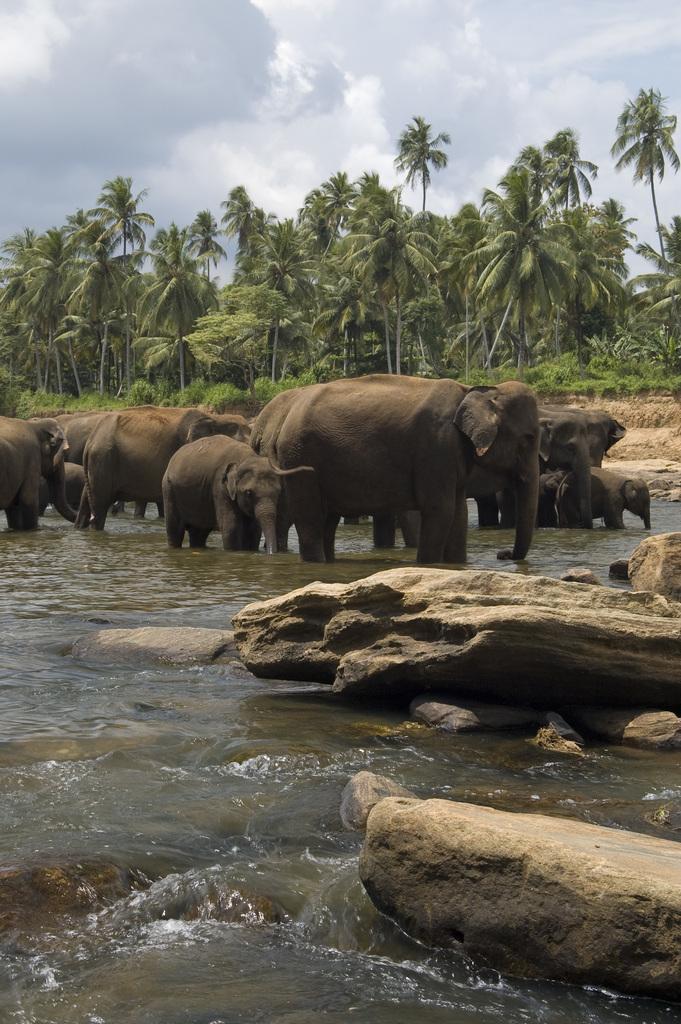Please provide a concise description of this image. As we can see in the image there is water, rocks, elephants and trees. On the top there is sky. 